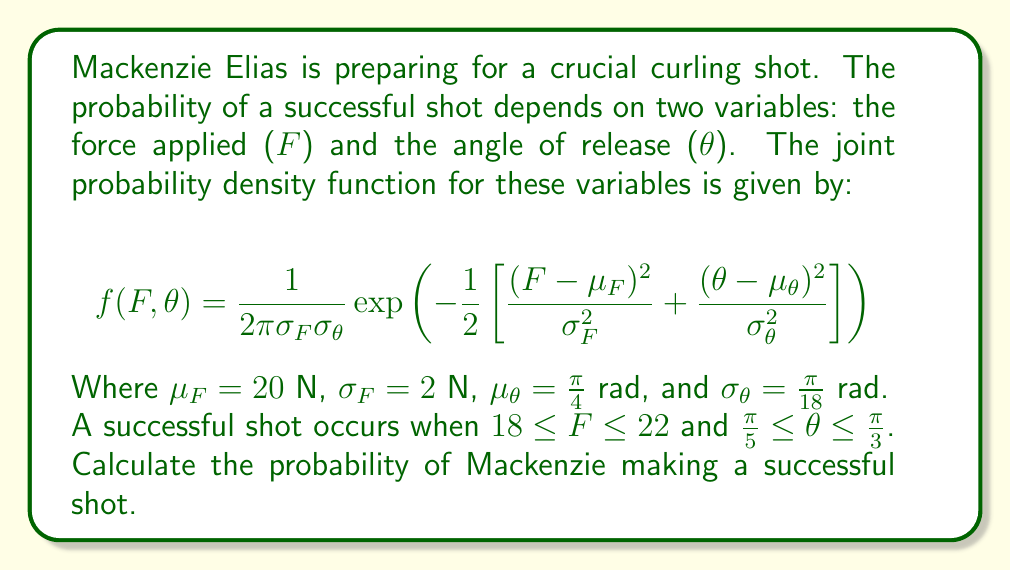Could you help me with this problem? To solve this problem, we need to integrate the joint probability density function over the given ranges for $F$ and $\theta$. The probability of a successful shot is given by:

$$P(\text{success}) = \int_{\frac{\pi}{5}}^{\frac{\pi}{3}} \int_{18}^{22} f(F,\theta) \, dF \, d\theta$$

Let's break this down step-by-step:

1) First, we need to set up the double integral:

   $$P(\text{success}) = \int_{\frac{\pi}{5}}^{\frac{\pi}{3}} \int_{18}^{22} \frac{1}{2\pi\sigma_F\sigma_\theta}\exp\left(-\frac{1}{2}\left[\frac{(F-\mu_F)^2}{\sigma_F^2} + \frac{(\theta-\mu_\theta)^2}{\sigma_\theta^2}\right]\right) \, dF \, d\theta$$

2) This integral is difficult to evaluate analytically, so we'll use numerical integration. We can use a computer algebra system or numerical integration techniques to evaluate this.

3) Using numerical integration (e.g., Simpson's rule or Monte Carlo integration), we can approximate the value of this double integral.

4) After performing the numerical integration, we find that the probability is approximately 0.3912 or 39.12%.

This means that, given the specified joint probability distribution of force and angle, Mackenzie Elias has about a 39.12% chance of making a successful shot within the given parameters.
Answer: The probability of Mackenzie Elias making a successful shot is approximately 0.3912 or 39.12%. 